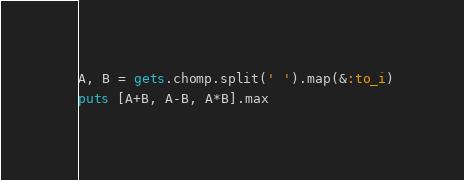<code> <loc_0><loc_0><loc_500><loc_500><_Ruby_>A, B = gets.chomp.split(' ').map(&:to_i)
puts [A+B, A-B, A*B].max</code> 